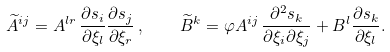<formula> <loc_0><loc_0><loc_500><loc_500>\widetilde { A } ^ { i j } = A ^ { l r } \, \frac { \partial s _ { i } } { \partial \xi _ { l } } \frac { \partial s _ { j } } { \partial \xi _ { r } } \, , \quad \widetilde { B } ^ { k } = \varphi A ^ { i j } \, \frac { \partial ^ { 2 } s _ { k } } { \partial \xi _ { i } \partial \xi _ { j } } + B ^ { l } \frac { \partial s _ { k } } { \partial \xi _ { l } } .</formula> 